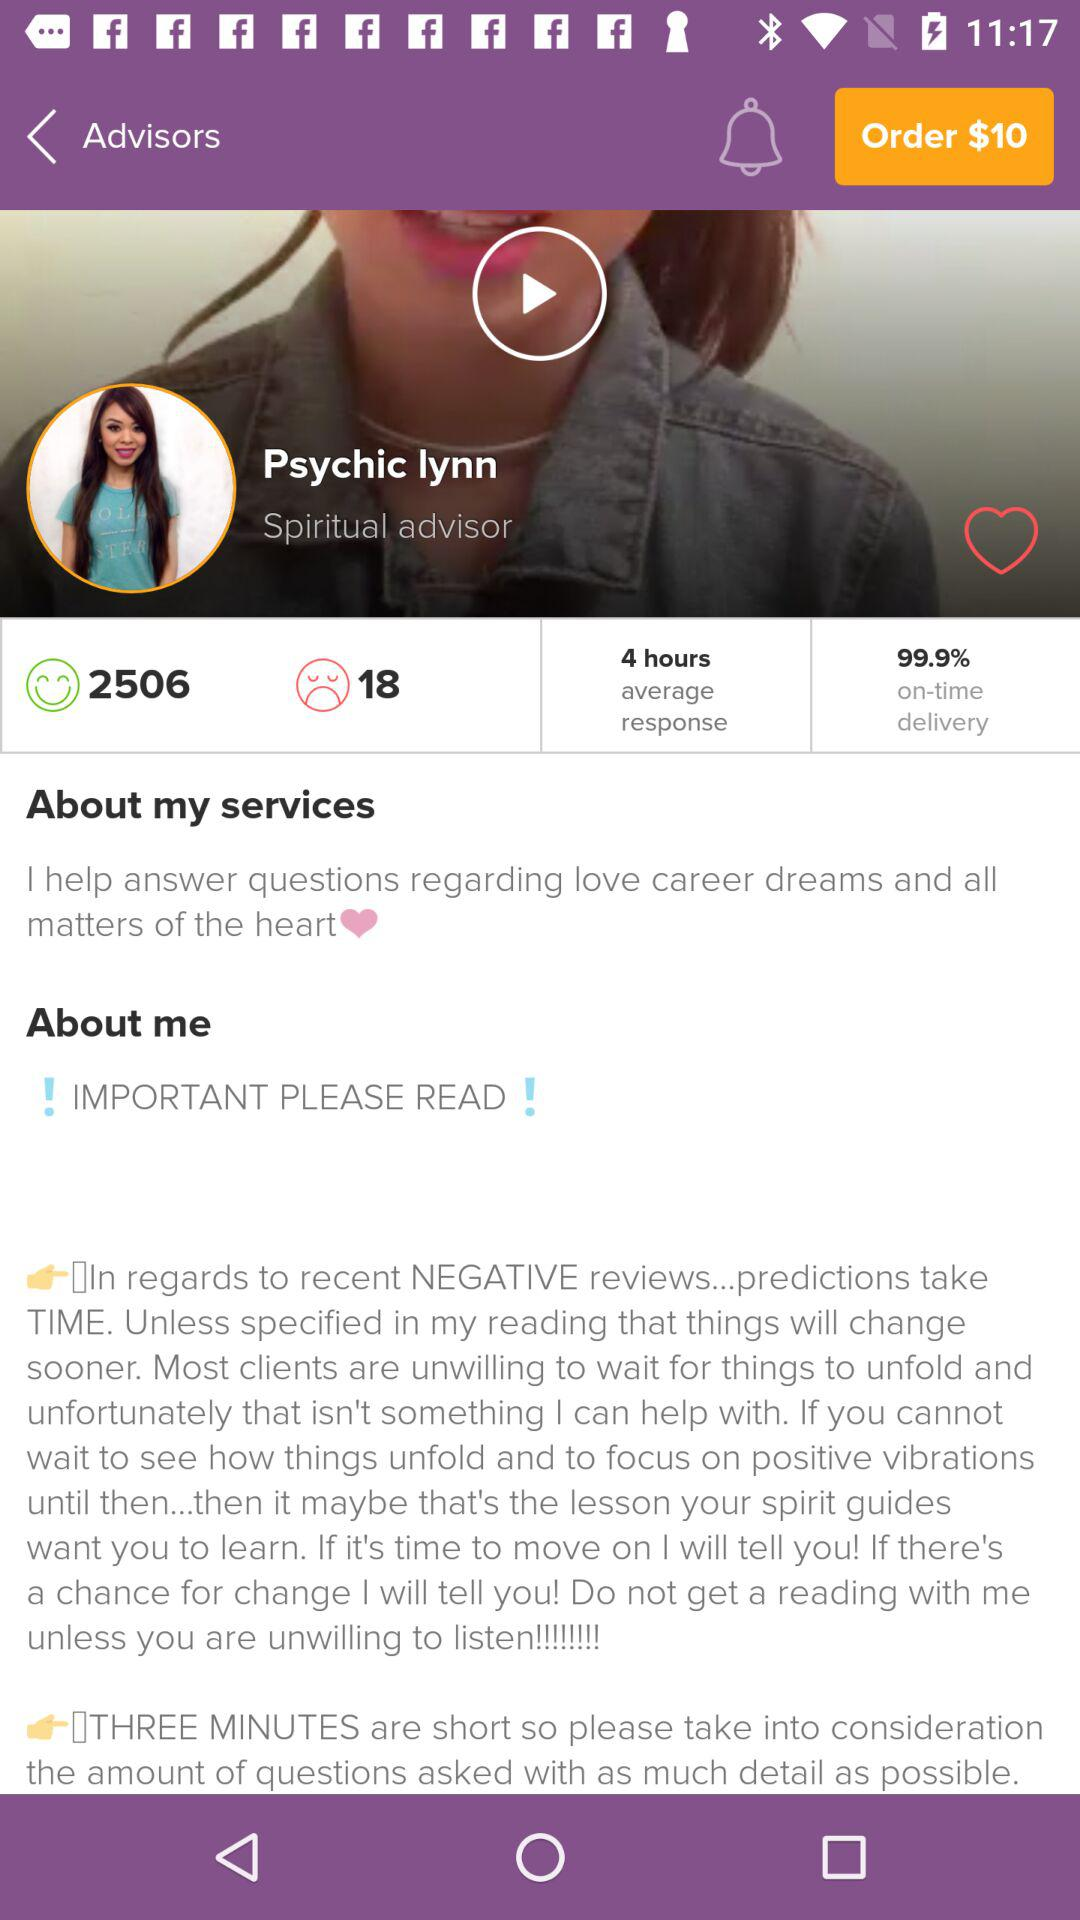How many happy users are there here? There are 2506 happy users. 